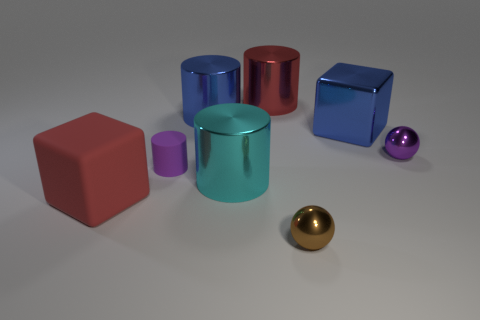Subtract all metallic cylinders. How many cylinders are left? 1 Subtract all yellow cylinders. Subtract all yellow balls. How many cylinders are left? 4 Add 1 purple balls. How many objects exist? 9 Subtract all spheres. How many objects are left? 6 Subtract all purple cylinders. Subtract all blue blocks. How many objects are left? 6 Add 4 purple cylinders. How many purple cylinders are left? 5 Add 2 small cyan objects. How many small cyan objects exist? 2 Subtract 0 red spheres. How many objects are left? 8 